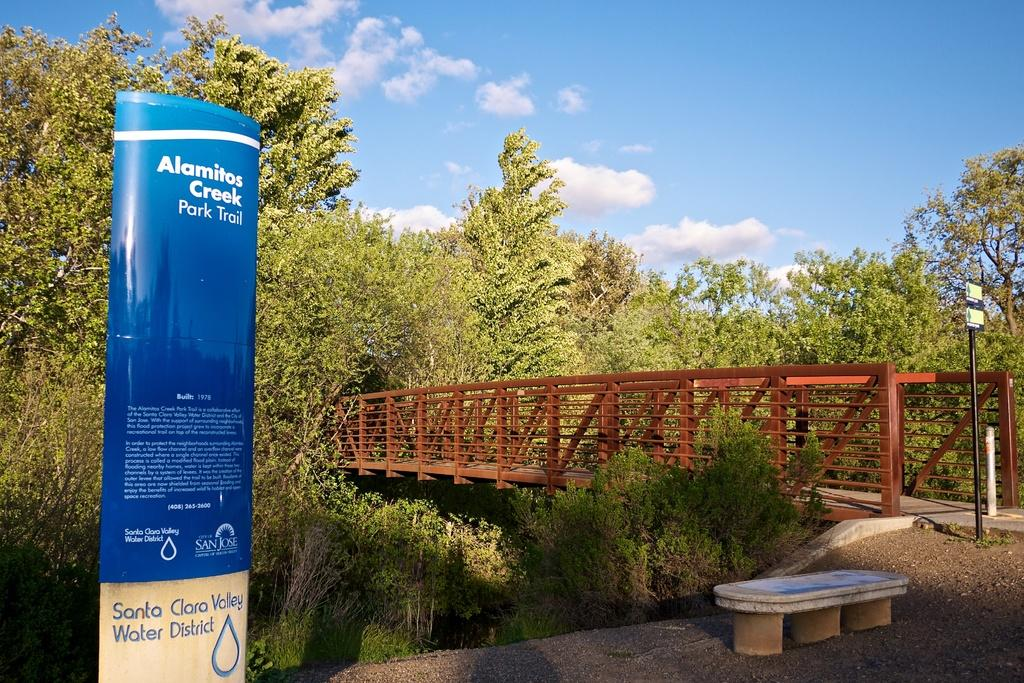What type of vegetation is present in the image? There are many trees in the image. What structure can be seen crossing a body of water? There is a bridge in the image. What object is standing upright in the image? There is a pole in the image. What type of seating is available in the image? There is a bench on the ground in the image. What type of advertisement or announcement is present in the image? There is a hoarding in the image. How would you describe the weather based on the image? The sky is cloudy in the image. Can you see the moon in the image? There is no moon visible in the image; it is focused on trees, a bridge, a pole, a bench, a hoarding, and the cloudy sky. Are there any ants crawling on the bench in the image? There is no mention of ants in the image, and it is not possible to determine their presence based on the provided facts. 